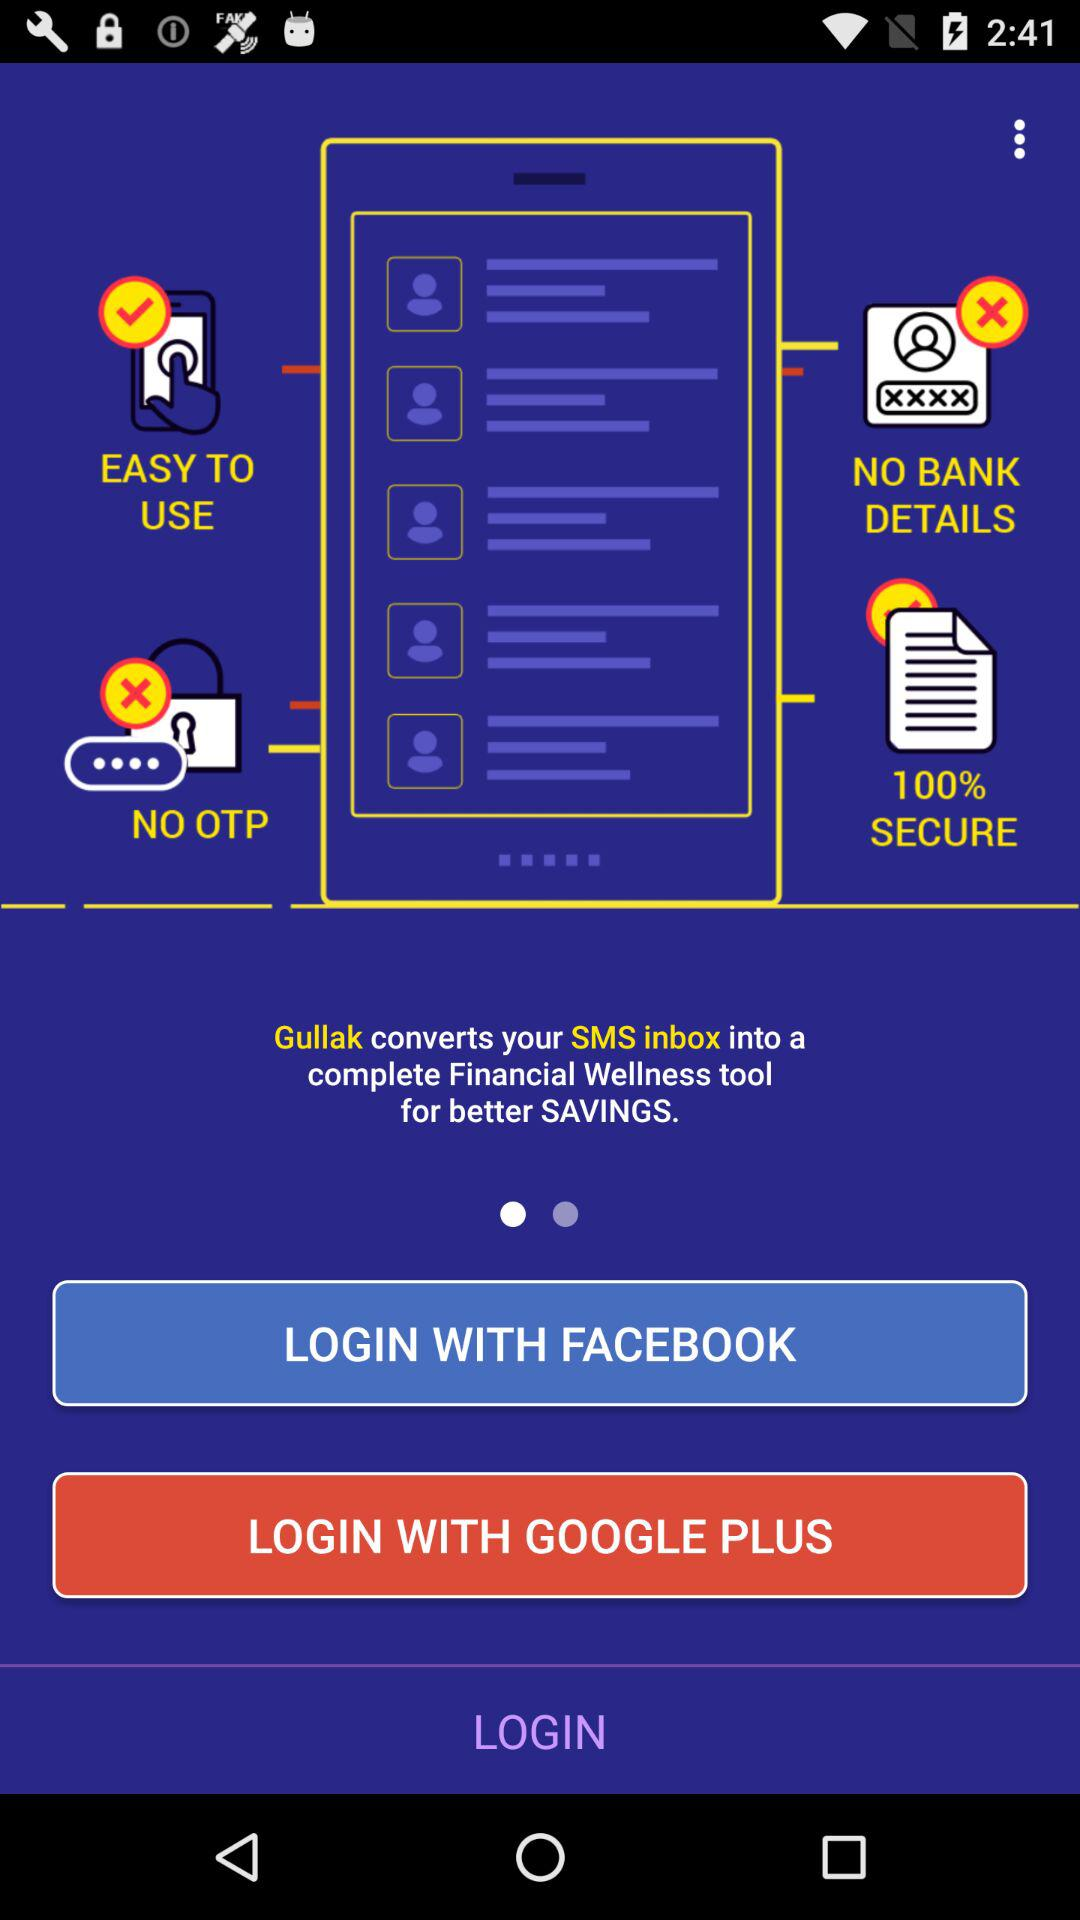What are the different options through which we can log in? The different options through which you can log in are "FACEBOOK" and "GOOGLE PLUS". 